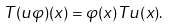<formula> <loc_0><loc_0><loc_500><loc_500>T ( u \varphi ) ( x ) = \varphi ( x ) T u ( x ) .</formula> 